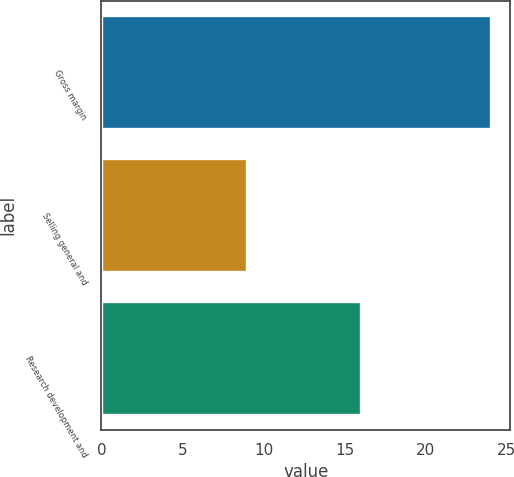<chart> <loc_0><loc_0><loc_500><loc_500><bar_chart><fcel>Gross margin<fcel>Selling general and<fcel>Research development and<nl><fcel>24<fcel>9<fcel>16<nl></chart> 